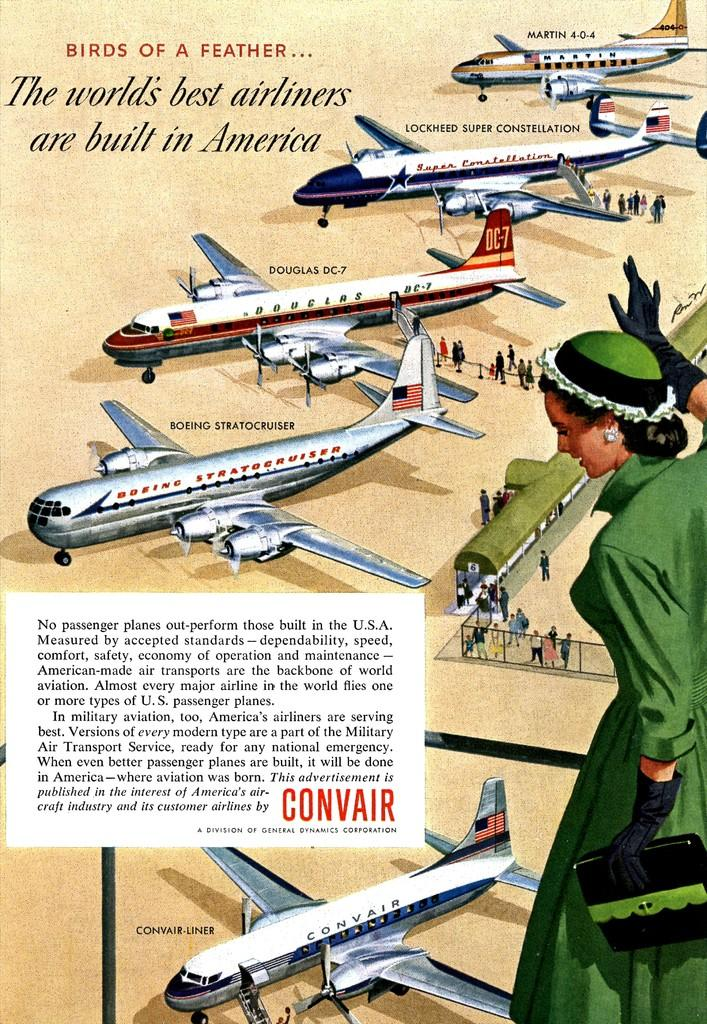Provide a one-sentence caption for the provided image. An old advertisement for Convair with information on their planes. 